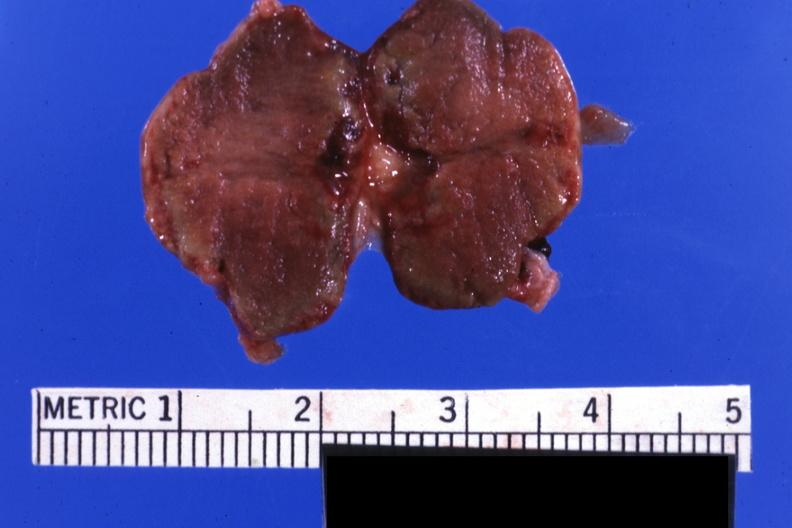what does this image show?
Answer the question using a single word or phrase. Fixed tissue but good color gland not recognizable as such 